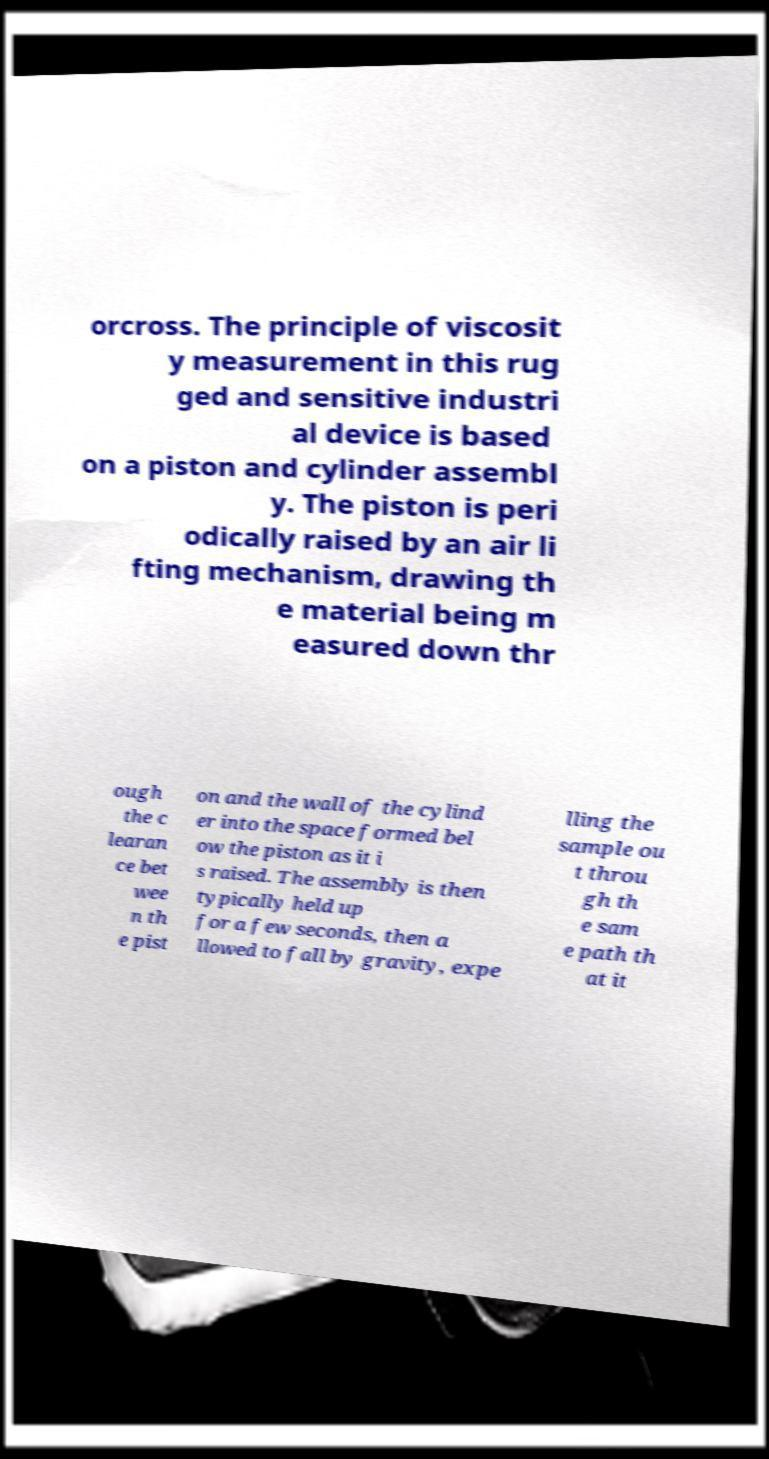I need the written content from this picture converted into text. Can you do that? orcross. The principle of viscosit y measurement in this rug ged and sensitive industri al device is based on a piston and cylinder assembl y. The piston is peri odically raised by an air li fting mechanism, drawing th e material being m easured down thr ough the c learan ce bet wee n th e pist on and the wall of the cylind er into the space formed bel ow the piston as it i s raised. The assembly is then typically held up for a few seconds, then a llowed to fall by gravity, expe lling the sample ou t throu gh th e sam e path th at it 